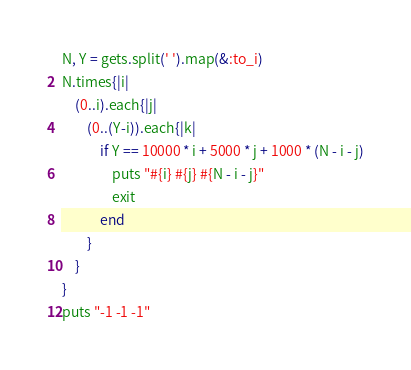<code> <loc_0><loc_0><loc_500><loc_500><_Ruby_>N, Y = gets.split(' ').map(&:to_i)
N.times{|i|
    (0..i).each{|j|
        (0..(Y-i)).each{|k|
            if Y == 10000 * i + 5000 * j + 1000 * (N - i - j)
                puts "#{i} #{j} #{N - i - j}"
                exit
            end
        }
    }
}
puts "-1 -1 -1"</code> 